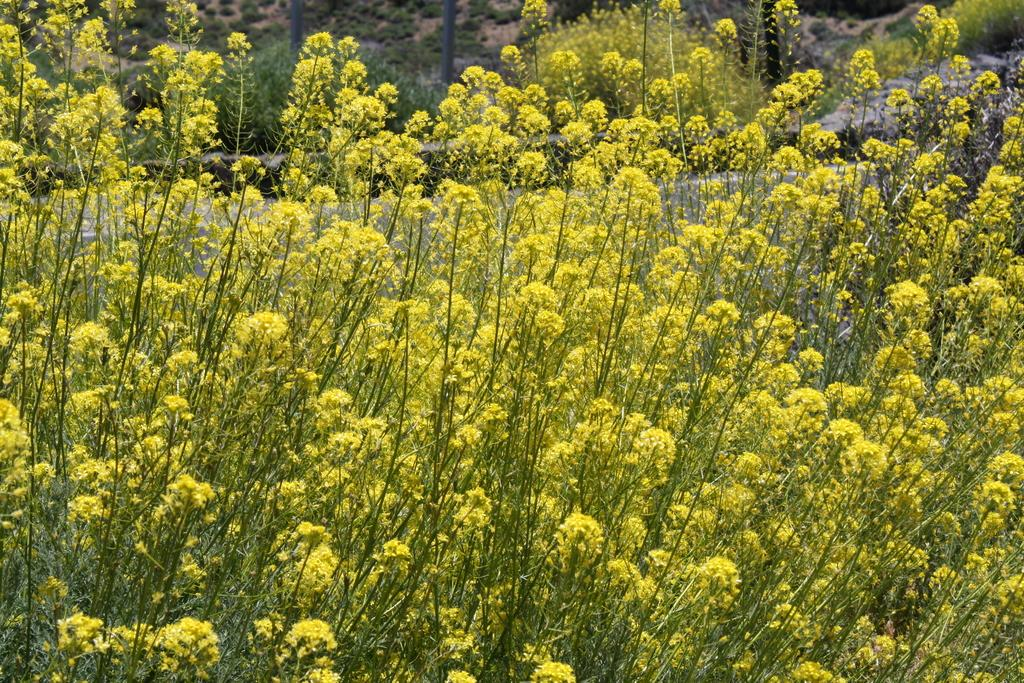What type of plants can be seen in the image? There are plants with flowers in the image. What else is visible in the image besides the plants? There are poles visible in the image. Where are the plants located? The plants are on the land. What type of cheese is being delivered in the image? There is no cheese or delivery depicted in the image; it features plants with flowers and poles. 